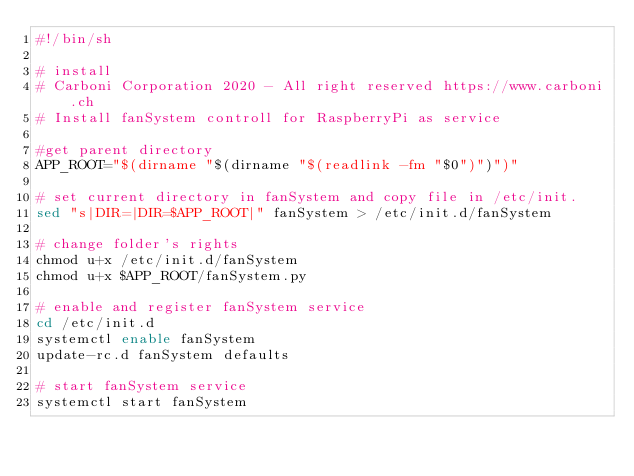Convert code to text. <code><loc_0><loc_0><loc_500><loc_500><_Bash_>#!/bin/sh

# install
# Carboni Corporation 2020 - All right reserved https://www.carboni.ch
# Install fanSystem controll for RaspberryPi as service

#get parent directory
APP_ROOT="$(dirname "$(dirname "$(readlink -fm "$0")")")"

# set current directory in fanSystem and copy file in /etc/init.
sed "s|DIR=|DIR=$APP_ROOT|" fanSystem > /etc/init.d/fanSystem

# change folder's rights
chmod u+x /etc/init.d/fanSystem
chmod u+x $APP_ROOT/fanSystem.py

# enable and register fanSystem service
cd /etc/init.d
systemctl enable fanSystem
update-rc.d fanSystem defaults

# start fanSystem service
systemctl start fanSystem</code> 